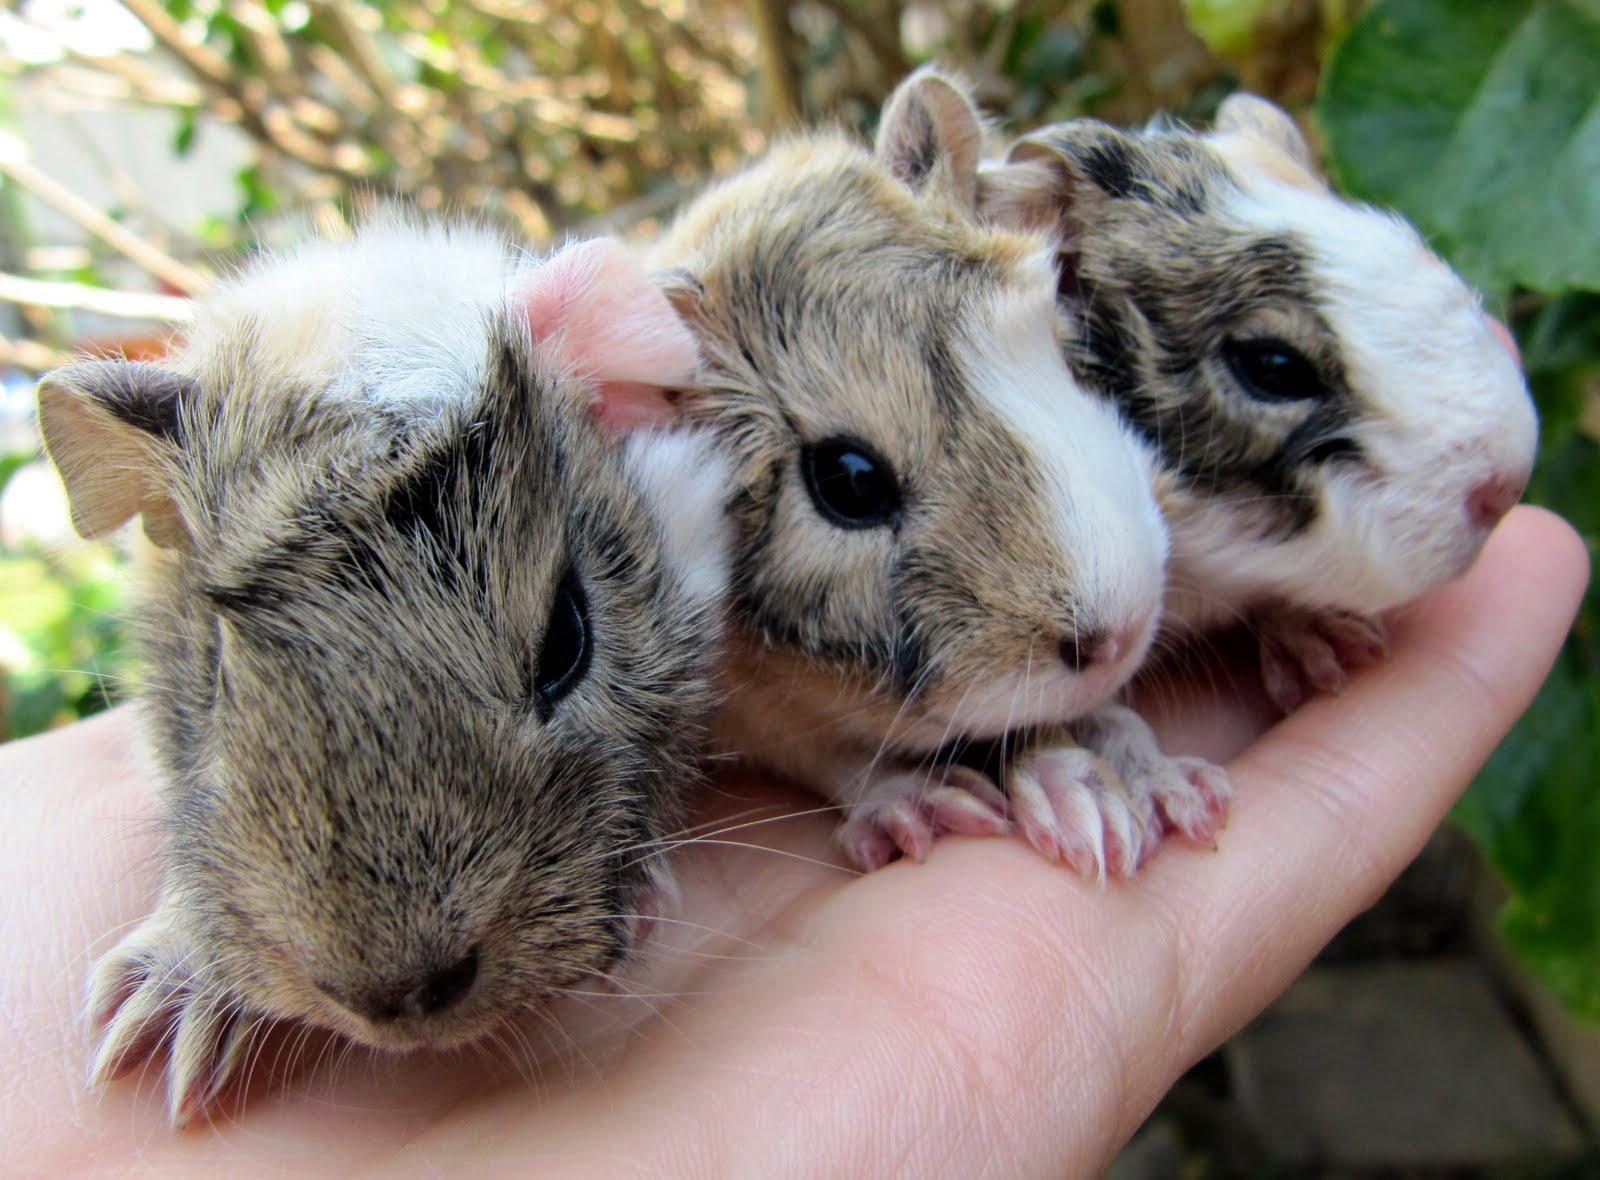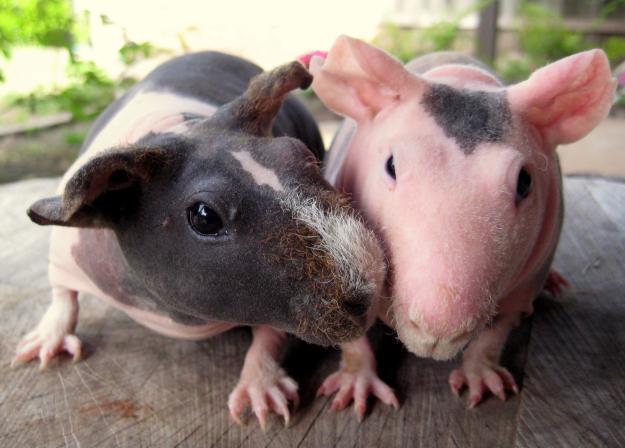The first image is the image on the left, the second image is the image on the right. For the images shown, is this caption "In one image, at least one rodent is being held in a human hand" true? Answer yes or no. Yes. The first image is the image on the left, the second image is the image on the right. Considering the images on both sides, is "An image shows an extended hand holding at least one hamster." valid? Answer yes or no. Yes. 